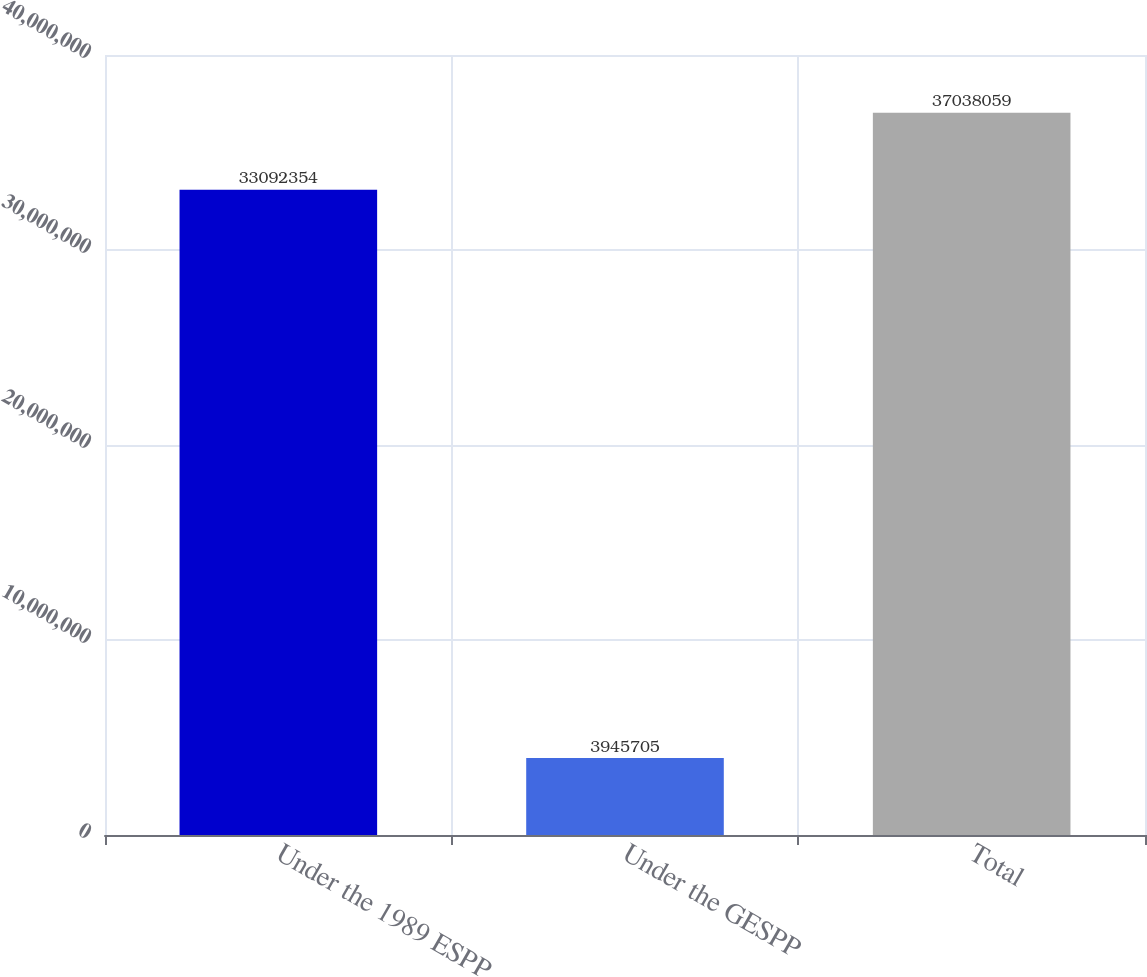<chart> <loc_0><loc_0><loc_500><loc_500><bar_chart><fcel>Under the 1989 ESPP<fcel>Under the GESPP<fcel>Total<nl><fcel>3.30924e+07<fcel>3.9457e+06<fcel>3.70381e+07<nl></chart> 